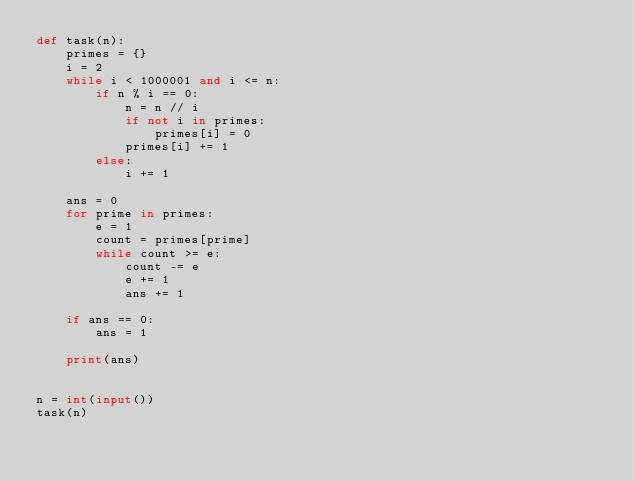Convert code to text. <code><loc_0><loc_0><loc_500><loc_500><_Python_>def task(n):
    primes = {}
    i = 2
    while i < 1000001 and i <= n:
        if n % i == 0:
            n = n // i
            if not i in primes:
                primes[i] = 0
            primes[i] += 1
        else:
            i += 1

    ans = 0
    for prime in primes:
        e = 1
        count = primes[prime]
        while count >= e:
            count -= e
            e += 1
            ans += 1

    if ans == 0:
        ans = 1

    print(ans)


n = int(input())
task(n)</code> 